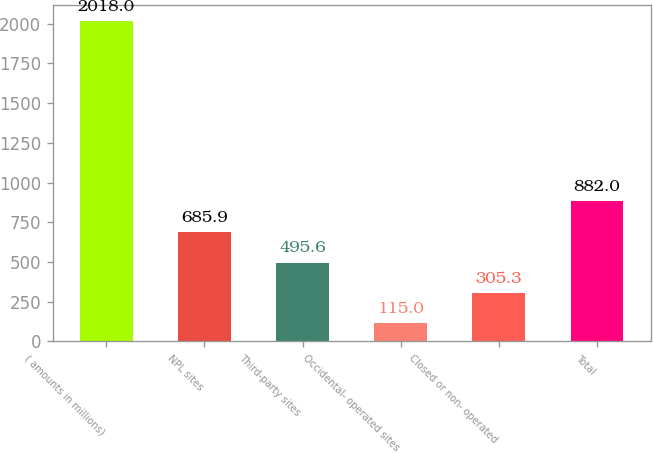<chart> <loc_0><loc_0><loc_500><loc_500><bar_chart><fcel>( amounts in millions)<fcel>NPL sites<fcel>Third-party sites<fcel>Occidental- operated sites<fcel>Closed or non- operated<fcel>Total<nl><fcel>2018<fcel>685.9<fcel>495.6<fcel>115<fcel>305.3<fcel>882<nl></chart> 